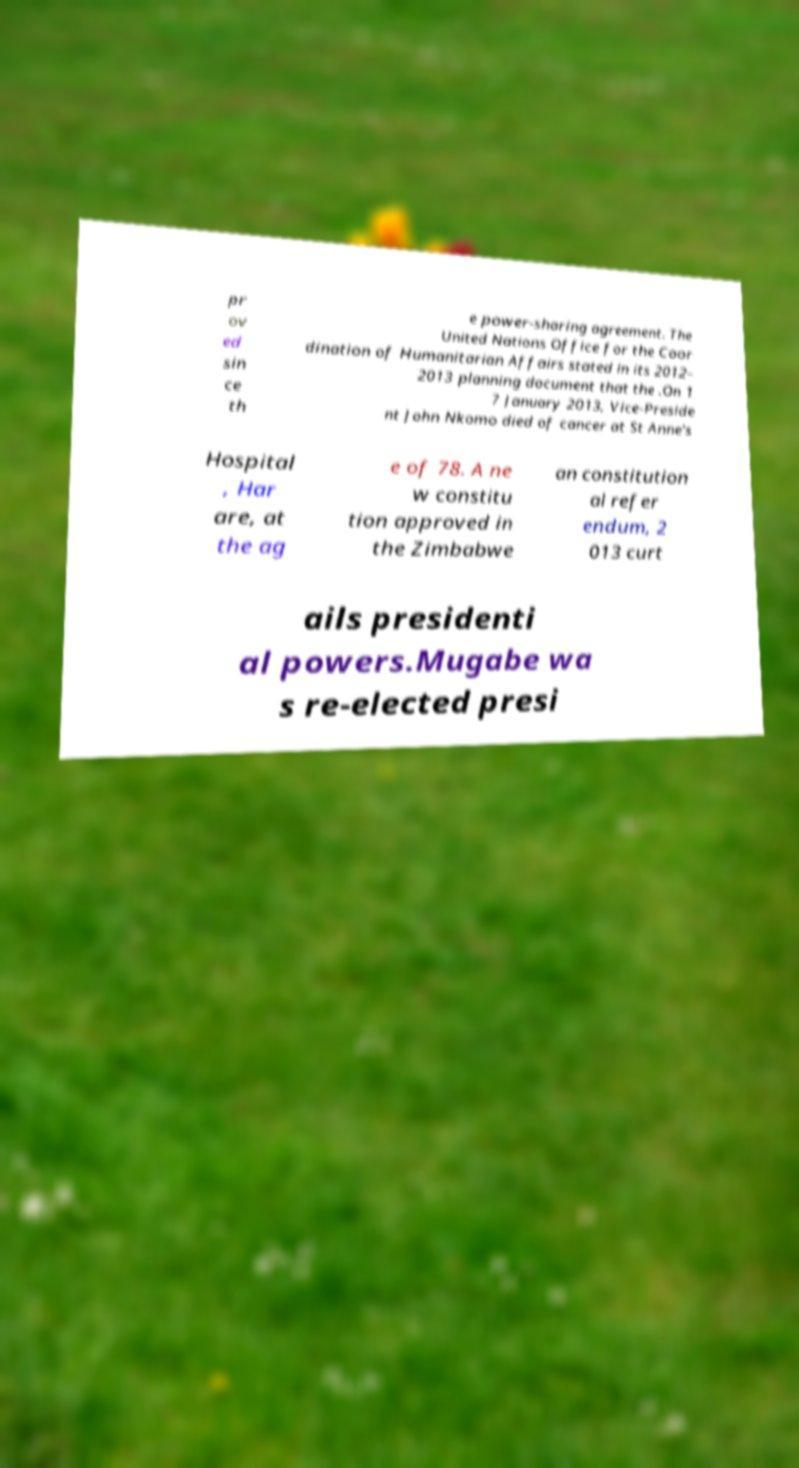Please identify and transcribe the text found in this image. pr ov ed sin ce th e power-sharing agreement. The United Nations Office for the Coor dination of Humanitarian Affairs stated in its 2012– 2013 planning document that the .On 1 7 January 2013, Vice-Preside nt John Nkomo died of cancer at St Anne's Hospital , Har are, at the ag e of 78. A ne w constitu tion approved in the Zimbabwe an constitution al refer endum, 2 013 curt ails presidenti al powers.Mugabe wa s re-elected presi 